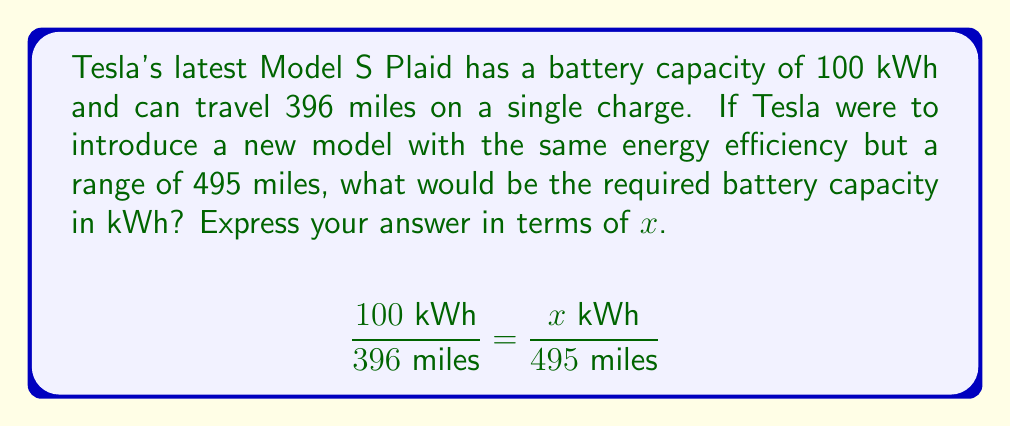Could you help me with this problem? To solve this problem, we'll use the concept of proportions. We know that the energy efficiency (kWh per mile) remains constant for both models.

1) Set up the proportion:
   $$\frac{100 \text{ kWh}}{396 \text{ miles}} = \frac{x \text{ kWh}}{495 \text{ miles}}$$

2) Cross multiply:
   $100 \cdot 495 = 396x$

3) Simplify:
   $49500 = 396x$

4) Divide both sides by 396:
   $$\frac{49500}{396} = x$$

5) Simplify:
   $125 = x$

Therefore, the new model would require a 125 kWh battery to achieve a range of 495 miles with the same energy efficiency as the Model S Plaid.
Answer: $x = 125$ kWh 